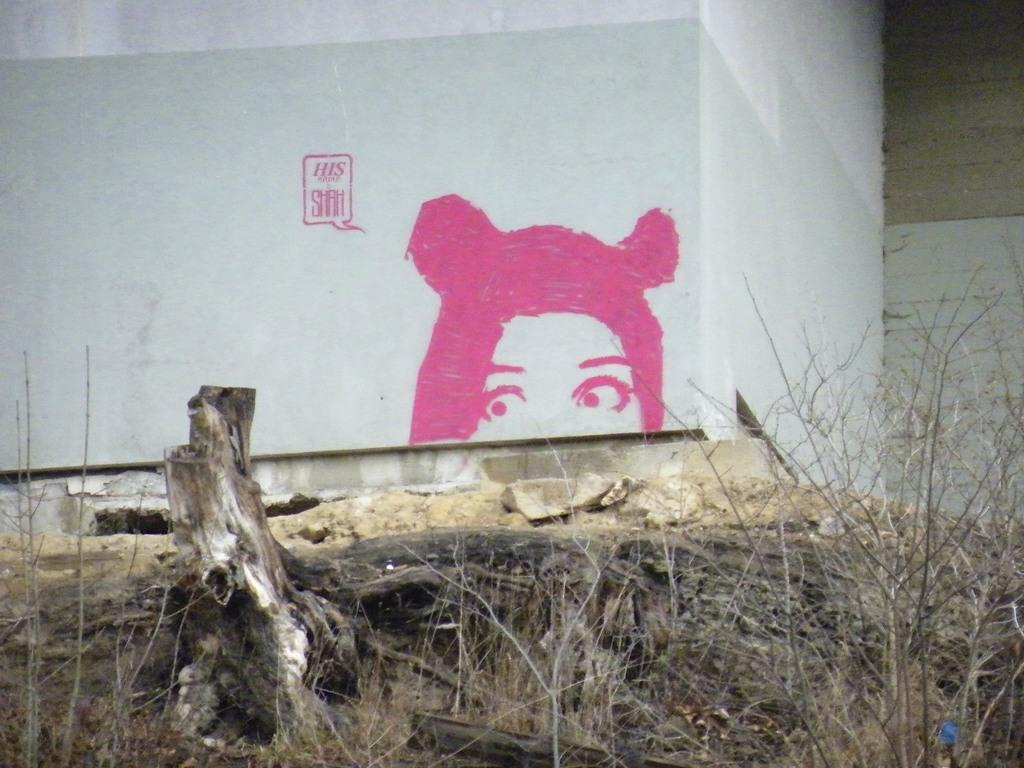What can be seen in the foreground of the image? In the foreground of the image, there are plants without leaves and a tree trunk. What is visible in the background of the image? In the background of the image, there are paintings on the wall. How many snails can be seen climbing the tree trunk in the image? There are no snails present in the image; it only features plants without leaves and a tree trunk. Where is the shelf located in the image? There is no shelf present in the image. 